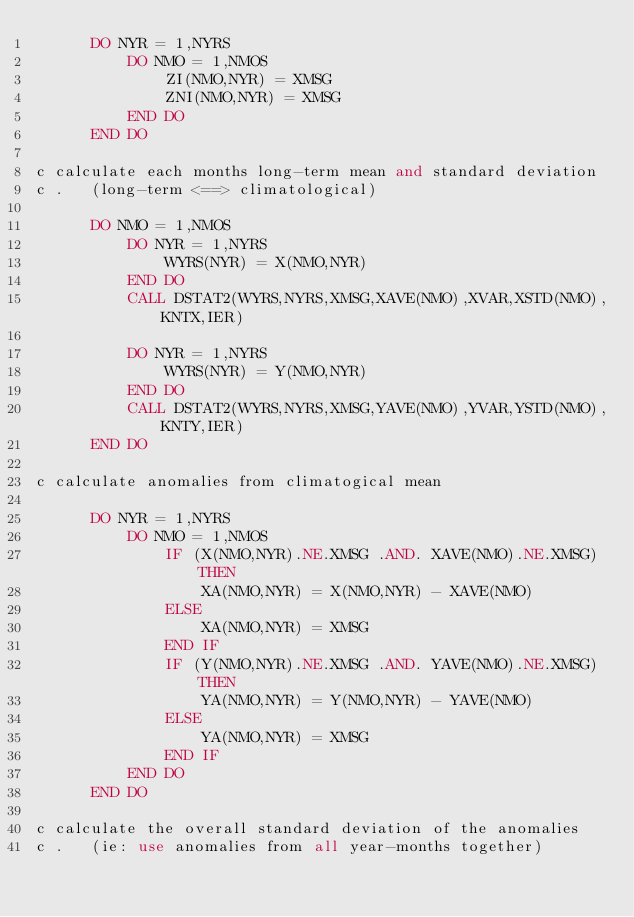Convert code to text. <code><loc_0><loc_0><loc_500><loc_500><_FORTRAN_>      DO NYR = 1,NYRS
          DO NMO = 1,NMOS
              ZI(NMO,NYR) = XMSG
              ZNI(NMO,NYR) = XMSG
          END DO
      END DO

c calculate each months long-term mean and standard deviation
c .   (long-term <==> climatological)

      DO NMO = 1,NMOS
          DO NYR = 1,NYRS
              WYRS(NYR) = X(NMO,NYR)
          END DO
          CALL DSTAT2(WYRS,NYRS,XMSG,XAVE(NMO),XVAR,XSTD(NMO),KNTX,IER)

          DO NYR = 1,NYRS
              WYRS(NYR) = Y(NMO,NYR)
          END DO
          CALL DSTAT2(WYRS,NYRS,XMSG,YAVE(NMO),YVAR,YSTD(NMO),KNTY,IER)
      END DO

c calculate anomalies from climatogical mean

      DO NYR = 1,NYRS
          DO NMO = 1,NMOS
              IF (X(NMO,NYR).NE.XMSG .AND. XAVE(NMO).NE.XMSG) THEN
                  XA(NMO,NYR) = X(NMO,NYR) - XAVE(NMO)
              ELSE
                  XA(NMO,NYR) = XMSG
              END IF
              IF (Y(NMO,NYR).NE.XMSG .AND. YAVE(NMO).NE.XMSG) THEN
                  YA(NMO,NYR) = Y(NMO,NYR) - YAVE(NMO)
              ELSE
                  YA(NMO,NYR) = XMSG
              END IF
          END DO
      END DO

c calculate the overall standard deviation of the anomalies
c .   (ie: use anomalies from all year-months together)
</code> 